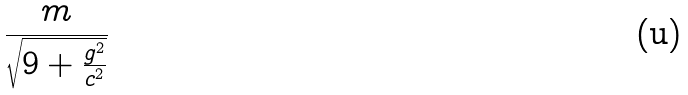Convert formula to latex. <formula><loc_0><loc_0><loc_500><loc_500>\frac { m } { \sqrt { 9 + \frac { g ^ { 2 } } { c ^ { 2 } } } }</formula> 